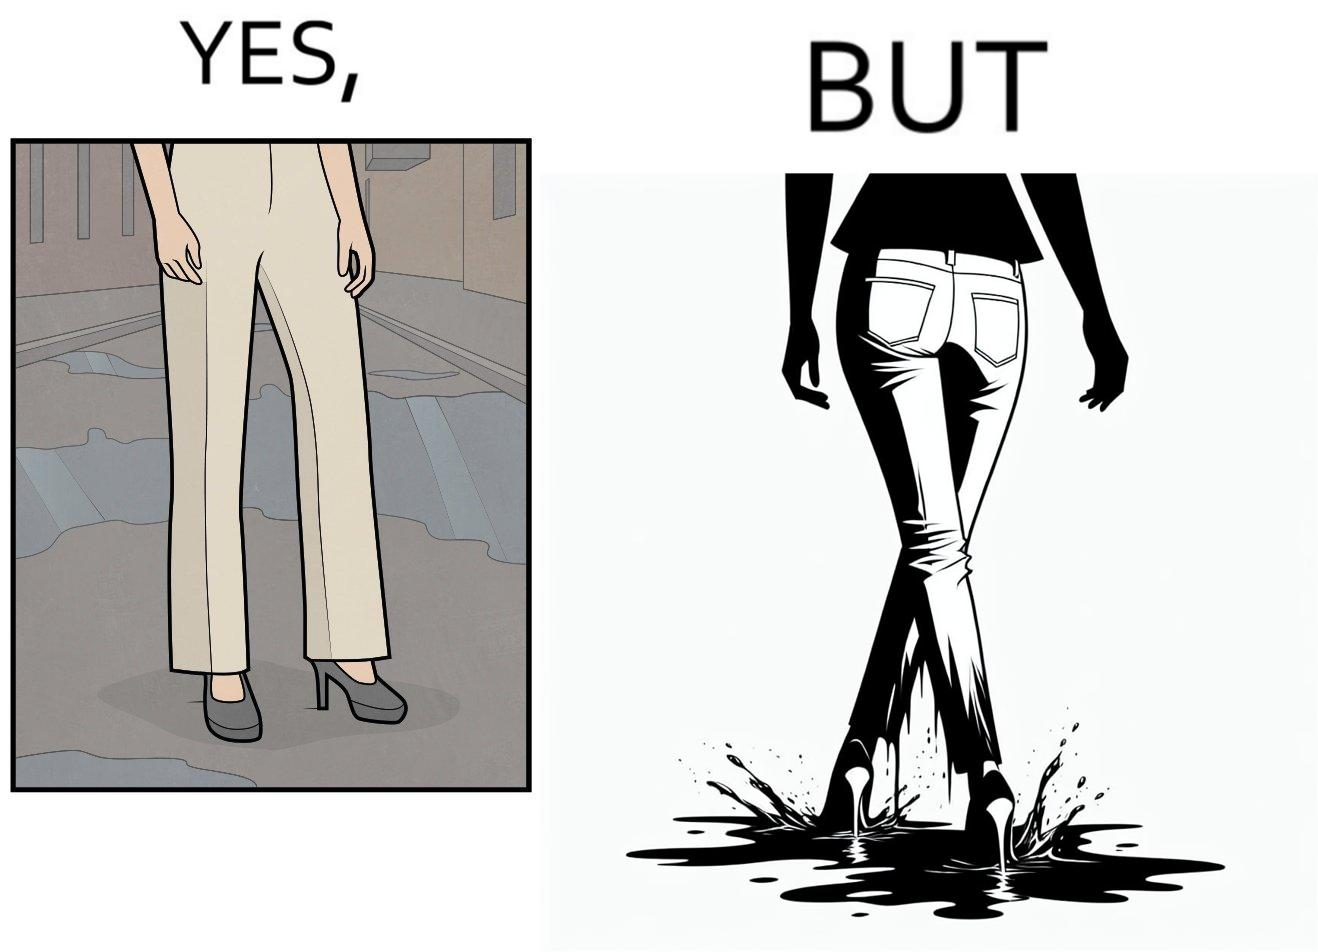Compare the left and right sides of this image. In the left part of the image: a person wearing white pants and high heels on a road filled with water. In the right part of the image: a person wearing white pants and high heels, but her pants are soaked in water when viewed from the back. 